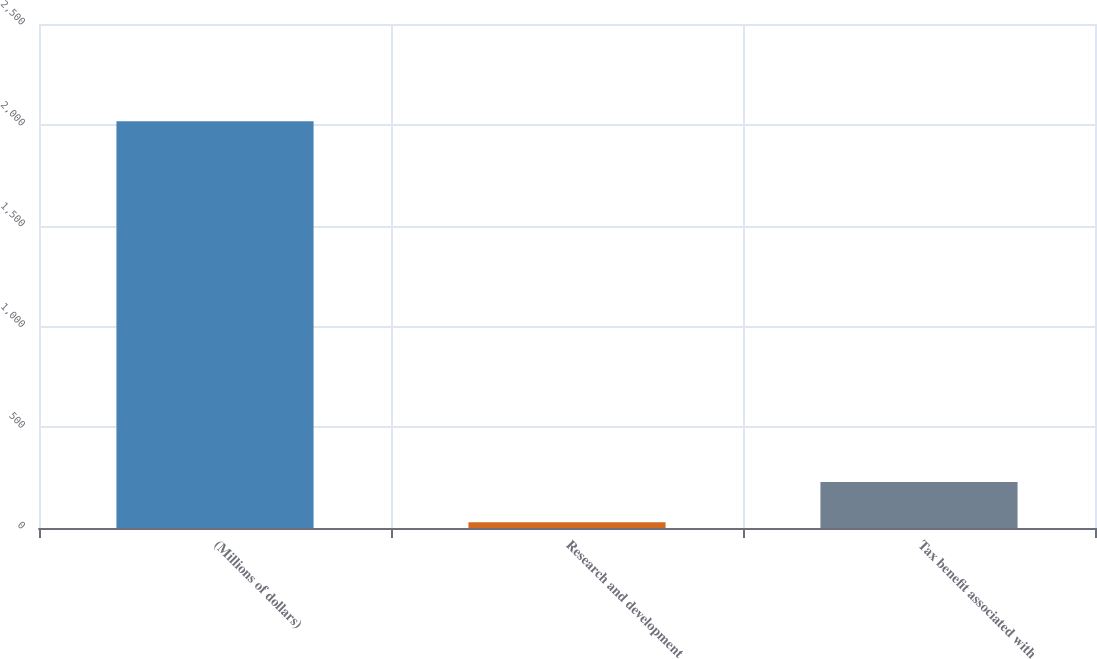Convert chart to OTSL. <chart><loc_0><loc_0><loc_500><loc_500><bar_chart><fcel>(Millions of dollars)<fcel>Research and development<fcel>Tax benefit associated with<nl><fcel>2018<fcel>29<fcel>227.9<nl></chart> 